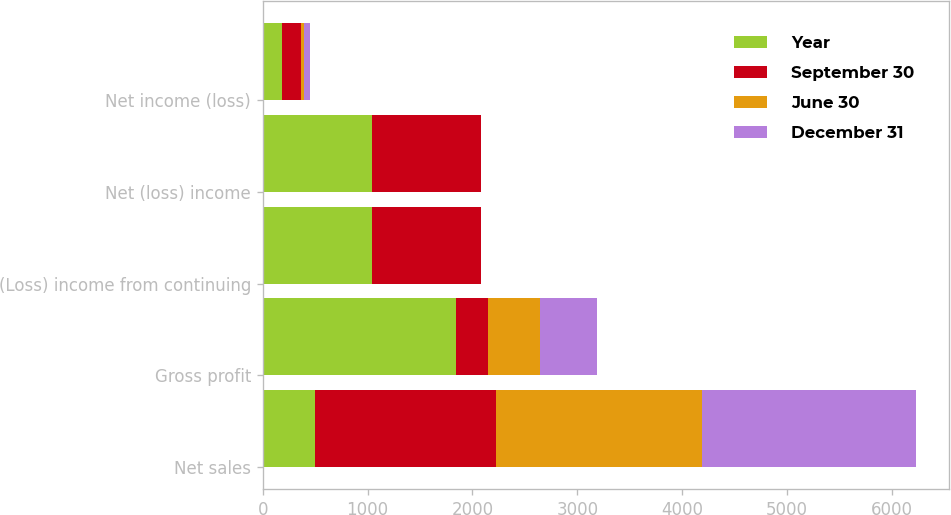Convert chart to OTSL. <chart><loc_0><loc_0><loc_500><loc_500><stacked_bar_chart><ecel><fcel>Net sales<fcel>Gross profit<fcel>(Loss) income from continuing<fcel>Net (loss) income<fcel>Net income (loss)<nl><fcel>Year<fcel>494<fcel>1840<fcel>1043<fcel>1043<fcel>183<nl><fcel>September 30<fcel>1735<fcel>308<fcel>1034<fcel>1034<fcel>185<nl><fcel>June 30<fcel>1957<fcel>494<fcel>5<fcel>5<fcel>28<nl><fcel>December 31<fcel>2048<fcel>546<fcel>3<fcel>3<fcel>55<nl></chart> 